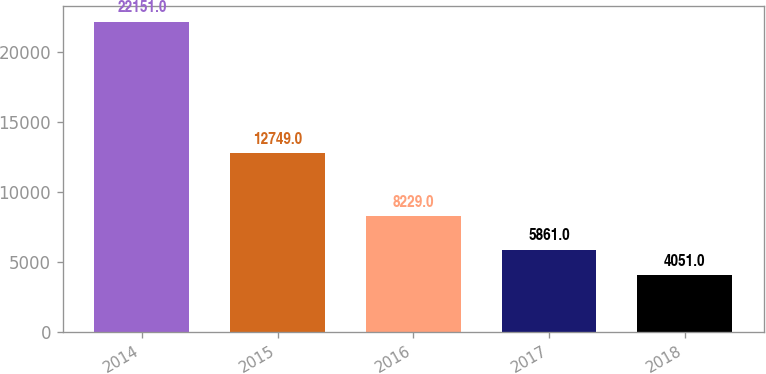<chart> <loc_0><loc_0><loc_500><loc_500><bar_chart><fcel>2014<fcel>2015<fcel>2016<fcel>2017<fcel>2018<nl><fcel>22151<fcel>12749<fcel>8229<fcel>5861<fcel>4051<nl></chart> 